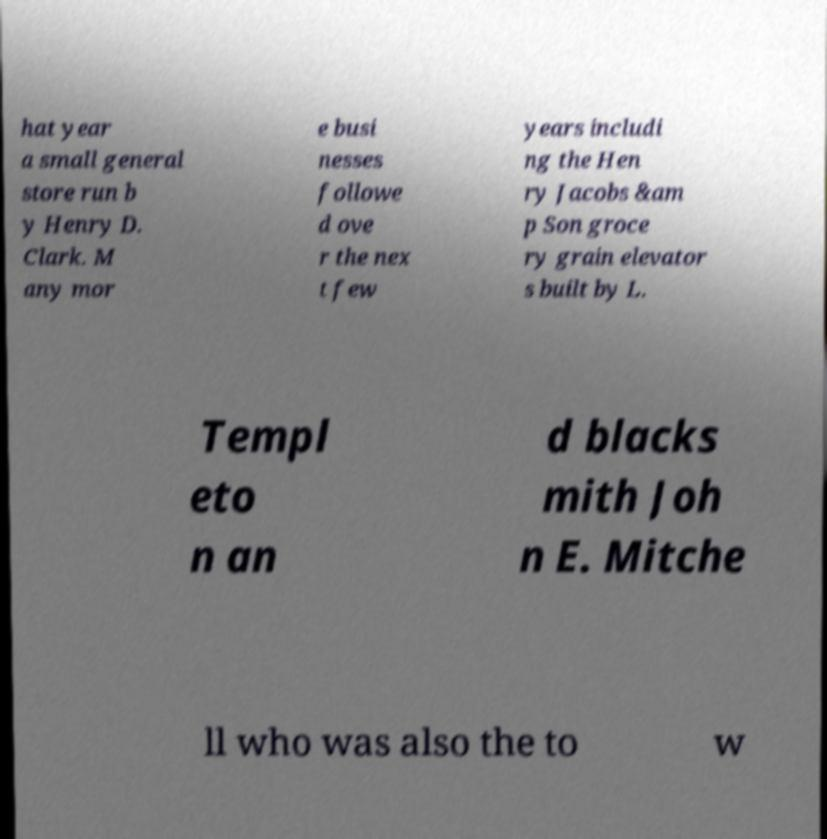Could you assist in decoding the text presented in this image and type it out clearly? hat year a small general store run b y Henry D. Clark. M any mor e busi nesses followe d ove r the nex t few years includi ng the Hen ry Jacobs &am p Son groce ry grain elevator s built by L. Templ eto n an d blacks mith Joh n E. Mitche ll who was also the to w 